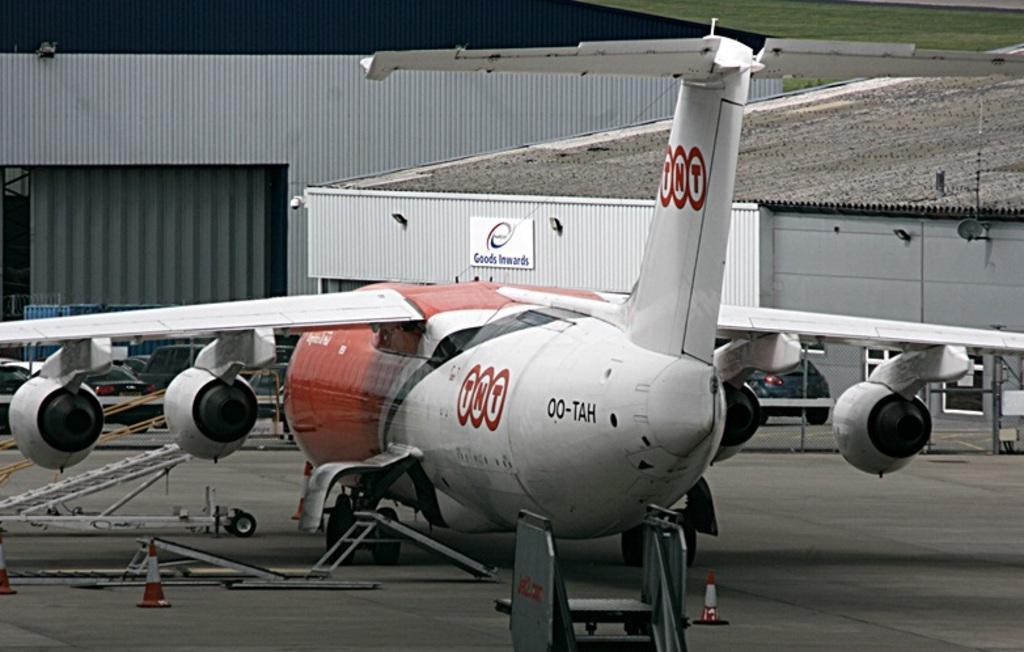Could you give a brief overview of what you see in this image? In the background we can see green grass, sheds. In this picture we can see an airplane and few objects. At the bottom portion of the picture we can see the road and traffic cones. 